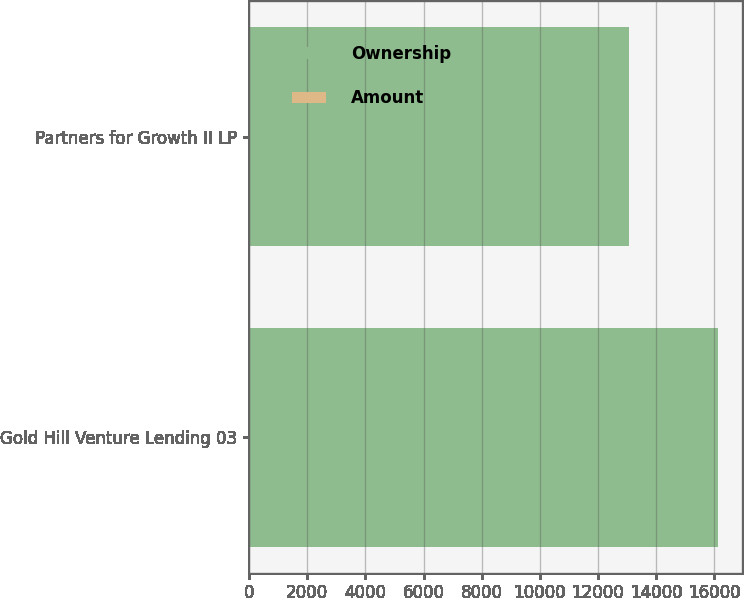Convert chart to OTSL. <chart><loc_0><loc_0><loc_500><loc_500><stacked_bar_chart><ecel><fcel>Gold Hill Venture Lending 03<fcel>Partners for Growth II LP<nl><fcel>Ownership<fcel>16134<fcel>13059<nl><fcel>Amount<fcel>9.3<fcel>24.2<nl></chart> 